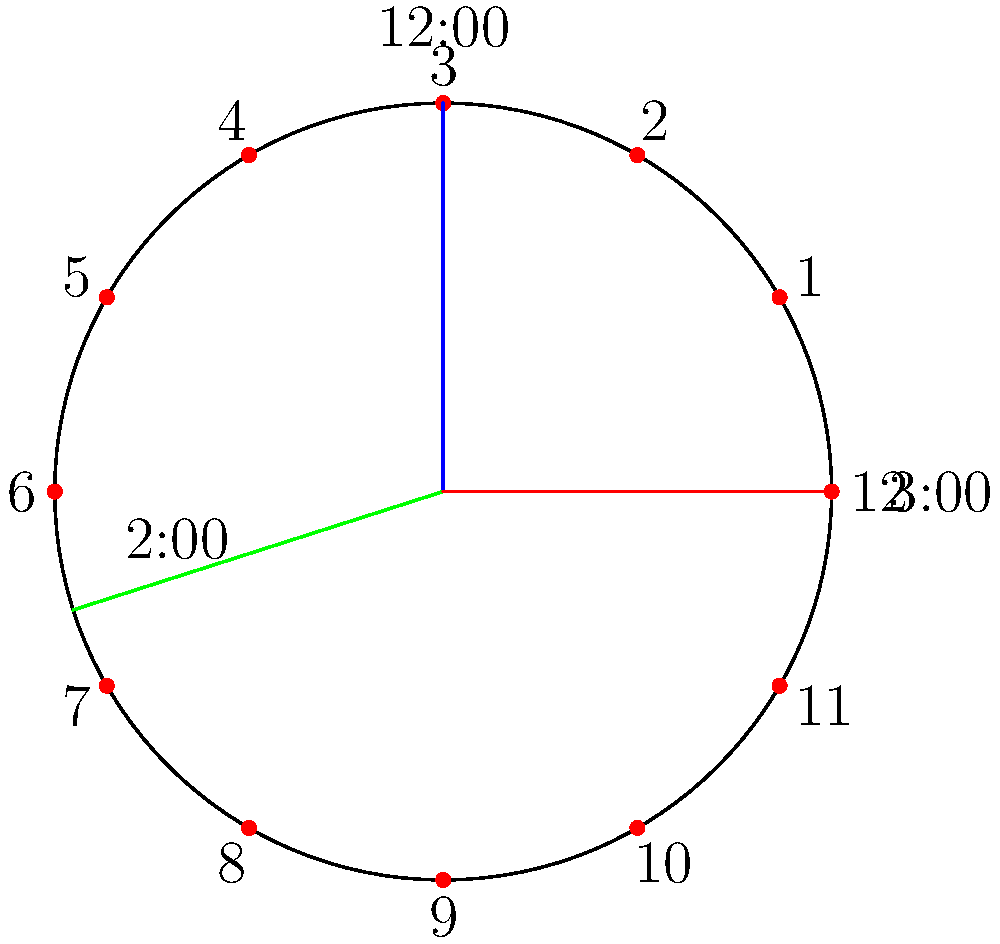When the clock shows 12:00, 2:00, and 3:00, what types of angles are formed between the hour hand at these times? Let's analyze the angles formed by the hour hand at 12:00, 2:00, and 3:00:

1. 12:00 to 2:00:
   - The angle between 12 and 2 on a clock face is 60°.
   - This is an acute angle (less than 90°).

2. 12:00 to 3:00:
   - The angle between 12 and 3 on a clock face is 90°.
   - This is a right angle.

3. 2:00 to 3:00:
   - The angle between 2 and 3 on a clock face is 30°.
   - This is also an acute angle.

Therefore, the types of angles formed are:
- Acute angle (between 12:00 and 2:00)
- Right angle (between 12:00 and 3:00)
- Acute angle (between 2:00 and 3:00)
Answer: Acute angle, right angle, acute angle 